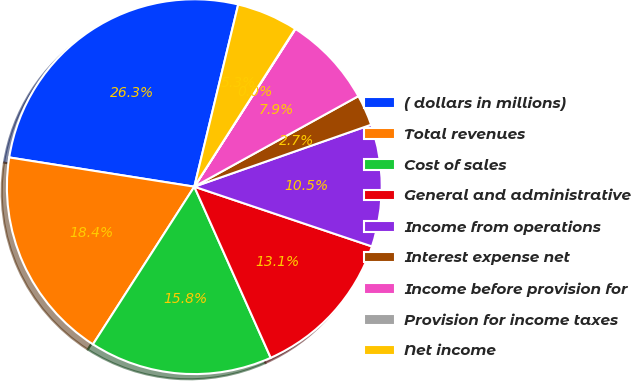Convert chart. <chart><loc_0><loc_0><loc_500><loc_500><pie_chart><fcel>( dollars in millions)<fcel>Total revenues<fcel>Cost of sales<fcel>General and administrative<fcel>Income from operations<fcel>Interest expense net<fcel>Income before provision for<fcel>Provision for income taxes<fcel>Net income<nl><fcel>26.27%<fcel>18.4%<fcel>15.78%<fcel>13.15%<fcel>10.53%<fcel>2.66%<fcel>7.9%<fcel>0.03%<fcel>5.28%<nl></chart> 